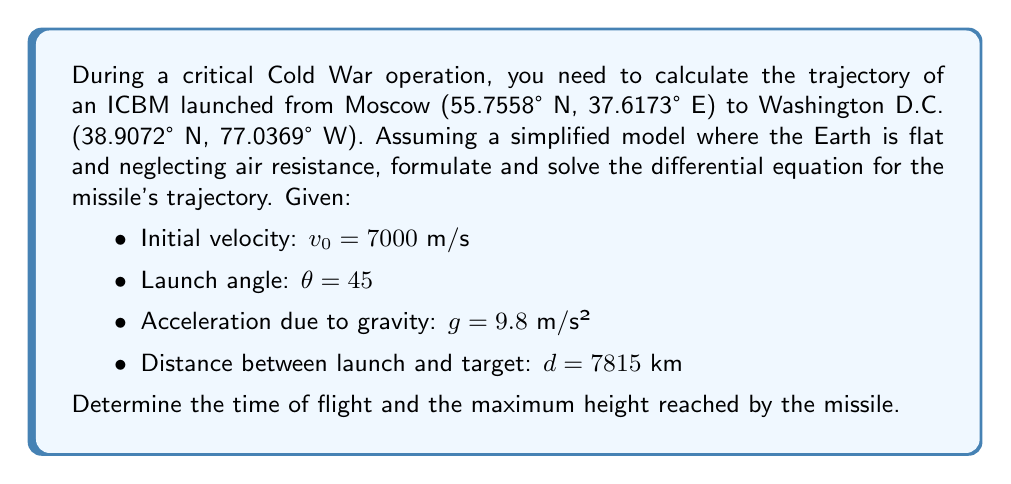What is the answer to this math problem? Let's approach this step-by-step:

1) First, we set up our coordinate system with the origin at the launch point, x-axis horizontal, and y-axis vertical.

2) The equations of motion for projectile motion are:

   $$x(t) = v_0 \cos(\theta) t$$
   $$y(t) = v_0 \sin(\theta) t - \frac{1}{2}gt^2$$

3) We can eliminate t from these equations to get the trajectory equation:

   $$y = x \tan(\theta) - \frac{gx^2}{2v_0^2\cos^2(\theta)}$$

4) To find the time of flight, we use the horizontal distance equation:

   $$d = v_0 \cos(\theta) t$$

   Solving for t:

   $$t = \frac{d}{v_0 \cos(\theta)} = \frac{7,815,000}{7000 \cos(45°)} \approx 1570.8 \text{ seconds}$$

5) To find the maximum height, we use the vertical velocity equation:

   $$v_y = v_0 \sin(\theta) - gt$$

   At the peak, $v_y = 0$, so:

   $$0 = v_0 \sin(\theta) - gt_{peak}$$
   $$t_{peak} = \frac{v_0 \sin(\theta)}{g} = \frac{7000 \sin(45°)}{9.8} \approx 504.6 \text{ seconds}$$

   Now we can plug this into the y(t) equation:

   $$y_{max} = v_0 \sin(\theta) t_{peak} - \frac{1}{2}gt_{peak}^2$$
   $$y_{max} = 7000 \sin(45°) (504.6) - \frac{1}{2}(9.8)(504.6)^2 \approx 1,264,155 \text{ meters}$$
Answer: Time of flight: 1570.8 s, Maximum height: 1,264,155 m 